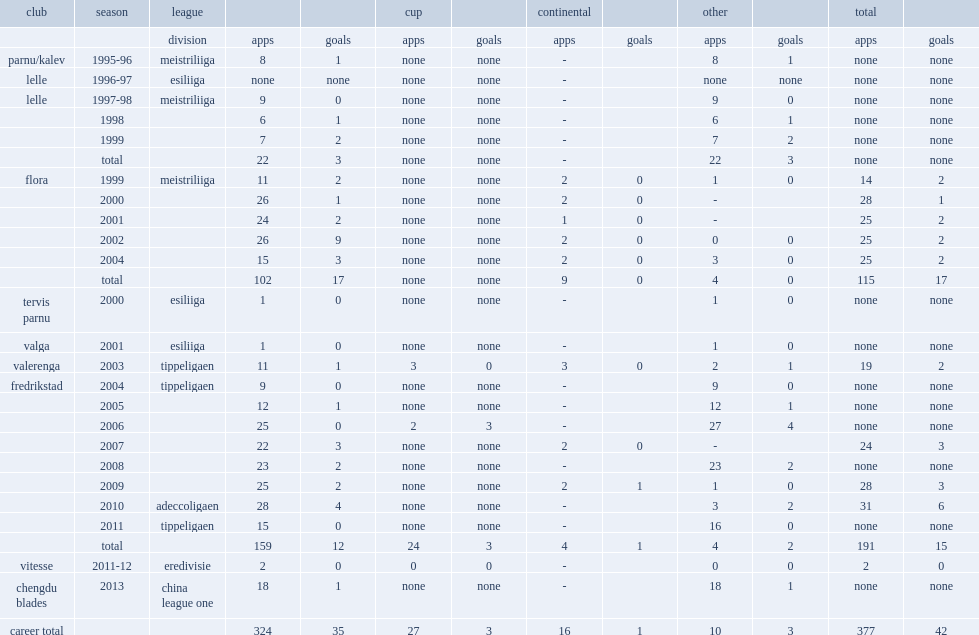Which club did piiroja play for in 2001? Flora. 